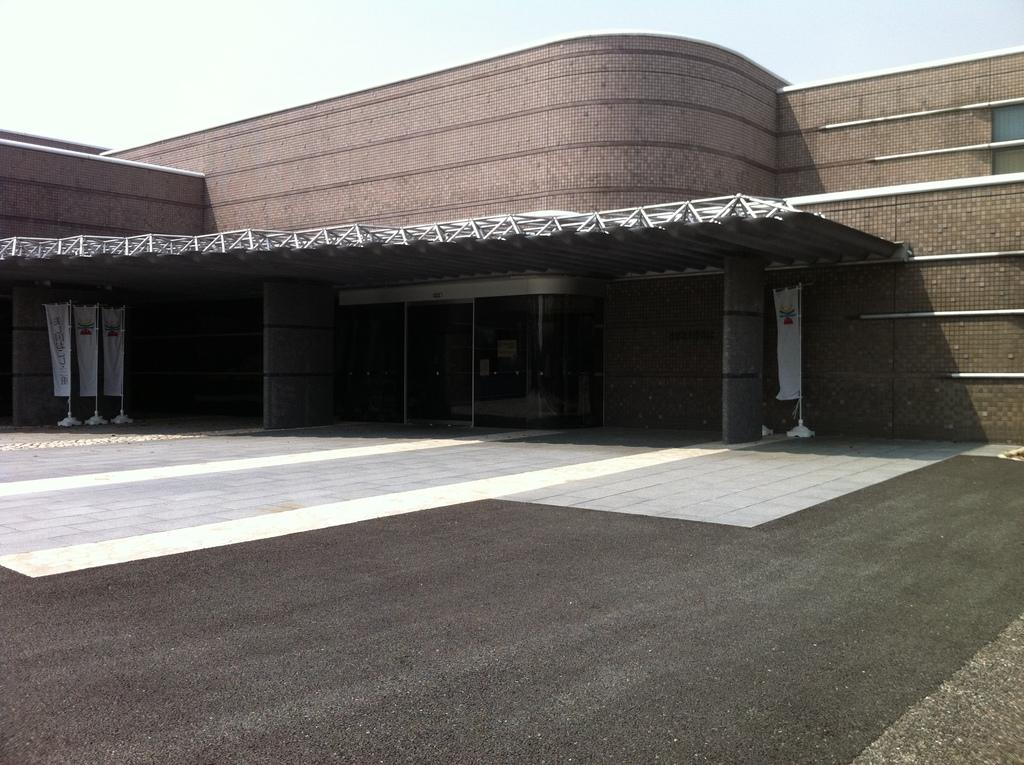What type of structure is visible in the background of the image? There is a building in the background of the image. What is located in front of the building? There is a road in front of the building. What can be seen on either side of the road? There are flags on either side of the road. What part of the natural environment is visible in the image? The sky is visible above the building and flags. What type of produce is being sold at the connection between the flags? There is no produce or connection between the flags in the image; it only shows flags on either side of the road. 